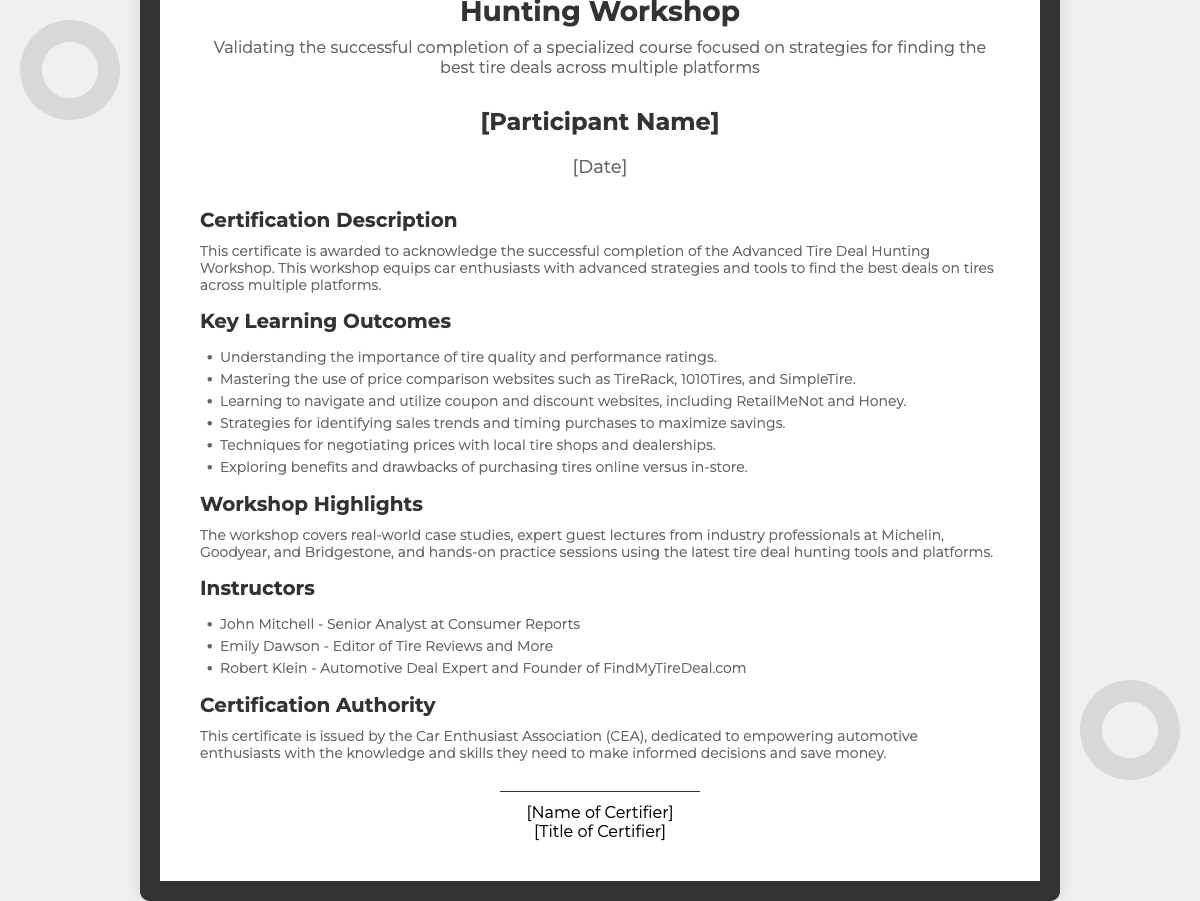What is the title of the certificate? The title is found at the top of the document and states the purpose of the certificate clearly.
Answer: Certificate of Completion for the Advanced Tire Deal Hunting Workshop Who is the certifying authority? The certifying authority is mentioned in the section that attributes the certificate's issuance, highlighting the entity responsible.
Answer: Car Enthusiast Association (CEA) What is the main focus of the workshop? The main focus is described in the subtitle and certification description sections, summarizing the theme of the workshop.
Answer: Strategies for finding the best tire deals across multiple platforms How many key learning outcomes are listed? The number of key learning outcomes can be counted from the list provided under the Key Learning Outcomes section.
Answer: Six Who is one of the instructors of the workshop? Instructor names are provided in the section detailing the workshop instructors.
Answer: John Mitchell What type of professionals guest lecture at the workshop? The type of professionals referenced in the document indicates the background of the guest lecturers and their relevance to the workshop.
Answer: Industry professionals What is one technique taught in the workshop? A specific technique is mentioned in the list of key learning outcomes, highlighting a particular skill that participants will learn.
Answer: Negotiating prices with local tire shops What are the workshop highlights? The highlights are described in a dedicated section that elaborates on what participants can expect from the workshop experience.
Answer: Real-world case studies, expert guest lectures, and hands-on practice sessions 